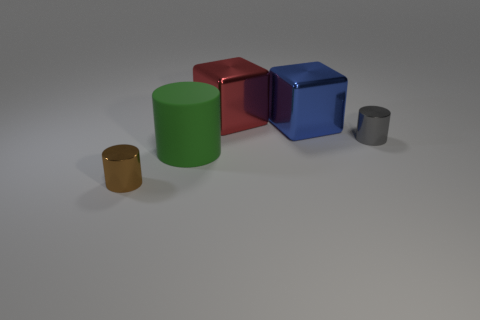Add 2 purple blocks. How many objects exist? 7 Subtract all cylinders. How many objects are left? 2 Subtract 0 cyan spheres. How many objects are left? 5 Subtract all red rubber cubes. Subtract all big metallic cubes. How many objects are left? 3 Add 5 tiny cylinders. How many tiny cylinders are left? 7 Add 5 big gray cylinders. How many big gray cylinders exist? 5 